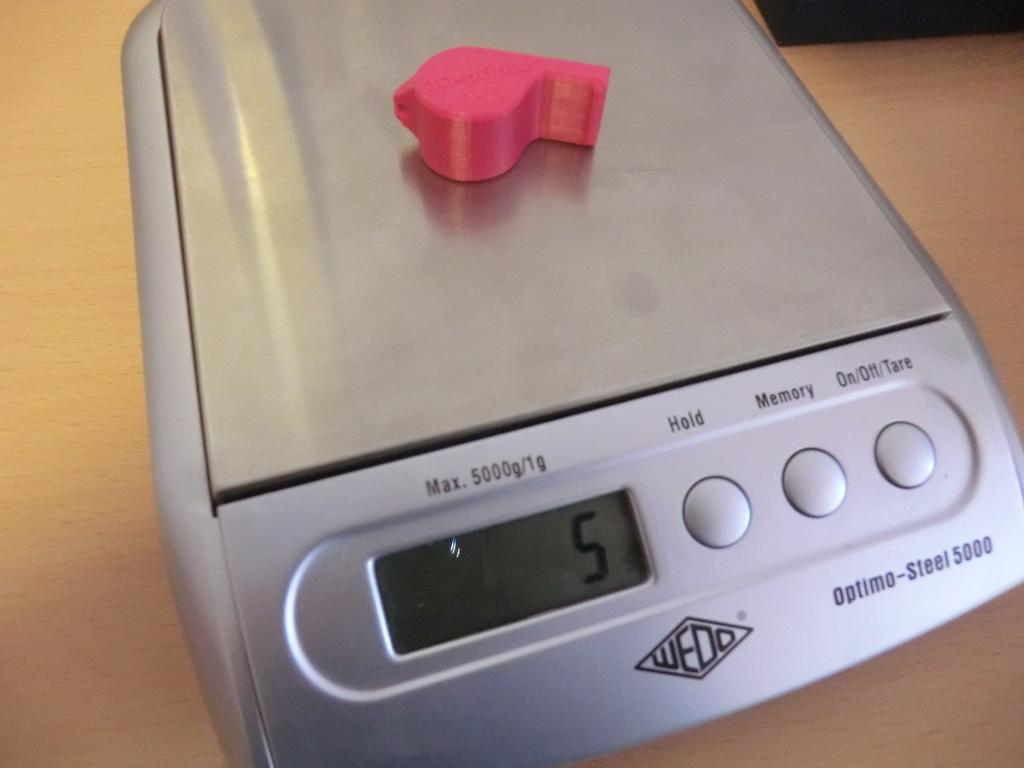What object is in the image that can be used to make a sound? There is a whistle in the image that can be used to make a sound. Where is the whistle placed in the image? The whistle is on a weighing machine. What is the weighing machine placed on in the image? The weighing machine is on a table. What type of iron is used to make the jail bars in the image? There is no iron or jail bars present in the image; it only features a whistle on a weighing machine on a table. 